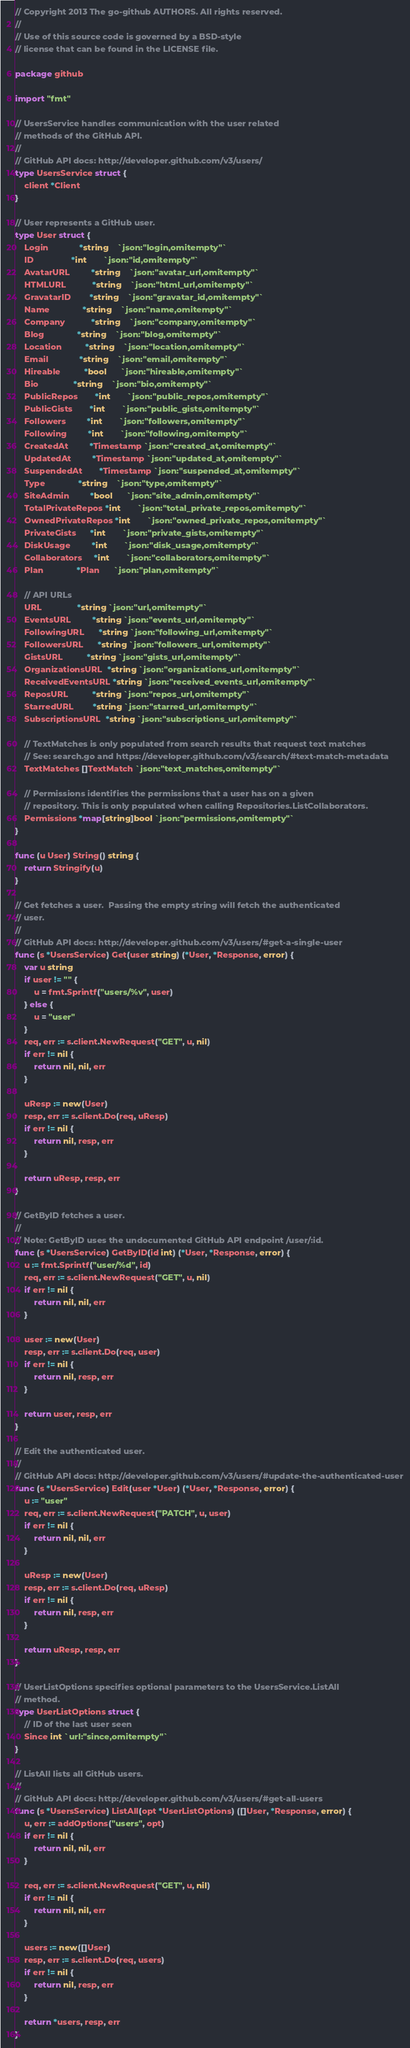Convert code to text. <code><loc_0><loc_0><loc_500><loc_500><_Go_>// Copyright 2013 The go-github AUTHORS. All rights reserved.
//
// Use of this source code is governed by a BSD-style
// license that can be found in the LICENSE file.

package github

import "fmt"

// UsersService handles communication with the user related
// methods of the GitHub API.
//
// GitHub API docs: http://developer.github.com/v3/users/
type UsersService struct {
	client *Client
}

// User represents a GitHub user.
type User struct {
	Login             *string    `json:"login,omitempty"`
	ID                *int       `json:"id,omitempty"`
	AvatarURL         *string    `json:"avatar_url,omitempty"`
	HTMLURL           *string    `json:"html_url,omitempty"`
	GravatarID        *string    `json:"gravatar_id,omitempty"`
	Name              *string    `json:"name,omitempty"`
	Company           *string    `json:"company,omitempty"`
	Blog              *string    `json:"blog,omitempty"`
	Location          *string    `json:"location,omitempty"`
	Email             *string    `json:"email,omitempty"`
	Hireable          *bool      `json:"hireable,omitempty"`
	Bio               *string    `json:"bio,omitempty"`
	PublicRepos       *int       `json:"public_repos,omitempty"`
	PublicGists       *int       `json:"public_gists,omitempty"`
	Followers         *int       `json:"followers,omitempty"`
	Following         *int       `json:"following,omitempty"`
	CreatedAt         *Timestamp `json:"created_at,omitempty"`
	UpdatedAt         *Timestamp `json:"updated_at,omitempty"`
	SuspendedAt       *Timestamp `json:"suspended_at,omitempty"`
	Type              *string    `json:"type,omitempty"`
	SiteAdmin         *bool      `json:"site_admin,omitempty"`
	TotalPrivateRepos *int       `json:"total_private_repos,omitempty"`
	OwnedPrivateRepos *int       `json:"owned_private_repos,omitempty"`
	PrivateGists      *int       `json:"private_gists,omitempty"`
	DiskUsage         *int       `json:"disk_usage,omitempty"`
	Collaborators     *int       `json:"collaborators,omitempty"`
	Plan              *Plan      `json:"plan,omitempty"`

	// API URLs
	URL               *string `json:"url,omitempty"`
	EventsURL         *string `json:"events_url,omitempty"`
	FollowingURL      *string `json:"following_url,omitempty"`
	FollowersURL      *string `json:"followers_url,omitempty"`
	GistsURL          *string `json:"gists_url,omitempty"`
	OrganizationsURL  *string `json:"organizations_url,omitempty"`
	ReceivedEventsURL *string `json:"received_events_url,omitempty"`
	ReposURL          *string `json:"repos_url,omitempty"`
	StarredURL        *string `json:"starred_url,omitempty"`
	SubscriptionsURL  *string `json:"subscriptions_url,omitempty"`

	// TextMatches is only populated from search results that request text matches
	// See: search.go and https://developer.github.com/v3/search/#text-match-metadata
	TextMatches []TextMatch `json:"text_matches,omitempty"`

	// Permissions identifies the permissions that a user has on a given
	// repository. This is only populated when calling Repositories.ListCollaborators.
	Permissions *map[string]bool `json:"permissions,omitempty"`
}

func (u User) String() string {
	return Stringify(u)
}

// Get fetches a user.  Passing the empty string will fetch the authenticated
// user.
//
// GitHub API docs: http://developer.github.com/v3/users/#get-a-single-user
func (s *UsersService) Get(user string) (*User, *Response, error) {
	var u string
	if user != "" {
		u = fmt.Sprintf("users/%v", user)
	} else {
		u = "user"
	}
	req, err := s.client.NewRequest("GET", u, nil)
	if err != nil {
		return nil, nil, err
	}

	uResp := new(User)
	resp, err := s.client.Do(req, uResp)
	if err != nil {
		return nil, resp, err
	}

	return uResp, resp, err
}

// GetByID fetches a user.
//
// Note: GetByID uses the undocumented GitHub API endpoint /user/:id.
func (s *UsersService) GetByID(id int) (*User, *Response, error) {
	u := fmt.Sprintf("user/%d", id)
	req, err := s.client.NewRequest("GET", u, nil)
	if err != nil {
		return nil, nil, err
	}

	user := new(User)
	resp, err := s.client.Do(req, user)
	if err != nil {
		return nil, resp, err
	}

	return user, resp, err
}

// Edit the authenticated user.
//
// GitHub API docs: http://developer.github.com/v3/users/#update-the-authenticated-user
func (s *UsersService) Edit(user *User) (*User, *Response, error) {
	u := "user"
	req, err := s.client.NewRequest("PATCH", u, user)
	if err != nil {
		return nil, nil, err
	}

	uResp := new(User)
	resp, err := s.client.Do(req, uResp)
	if err != nil {
		return nil, resp, err
	}

	return uResp, resp, err
}

// UserListOptions specifies optional parameters to the UsersService.ListAll
// method.
type UserListOptions struct {
	// ID of the last user seen
	Since int `url:"since,omitempty"`
}

// ListAll lists all GitHub users.
//
// GitHub API docs: http://developer.github.com/v3/users/#get-all-users
func (s *UsersService) ListAll(opt *UserListOptions) ([]User, *Response, error) {
	u, err := addOptions("users", opt)
	if err != nil {
		return nil, nil, err
	}

	req, err := s.client.NewRequest("GET", u, nil)
	if err != nil {
		return nil, nil, err
	}

	users := new([]User)
	resp, err := s.client.Do(req, users)
	if err != nil {
		return nil, resp, err
	}

	return *users, resp, err
}
</code> 